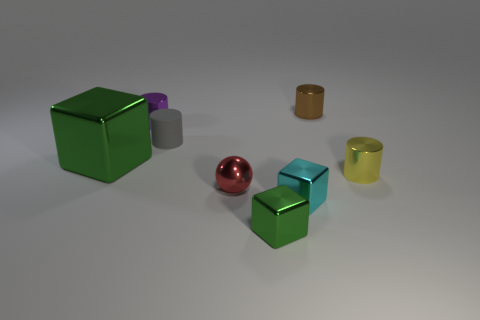What could be the function of these objects if they were part of a larger apparatus? If these objects were part of a larger apparatus, the cubes could serve as structural elements, the cylinders might act as containers or passageways, and the sphere could function as a pivot or joint within the mechanism. 